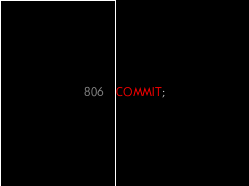Convert code to text. <code><loc_0><loc_0><loc_500><loc_500><_SQL_>
COMMIT;
</code> 